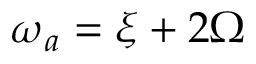<formula> <loc_0><loc_0><loc_500><loc_500>\omega _ { a } = \xi + 2 \Omega</formula> 